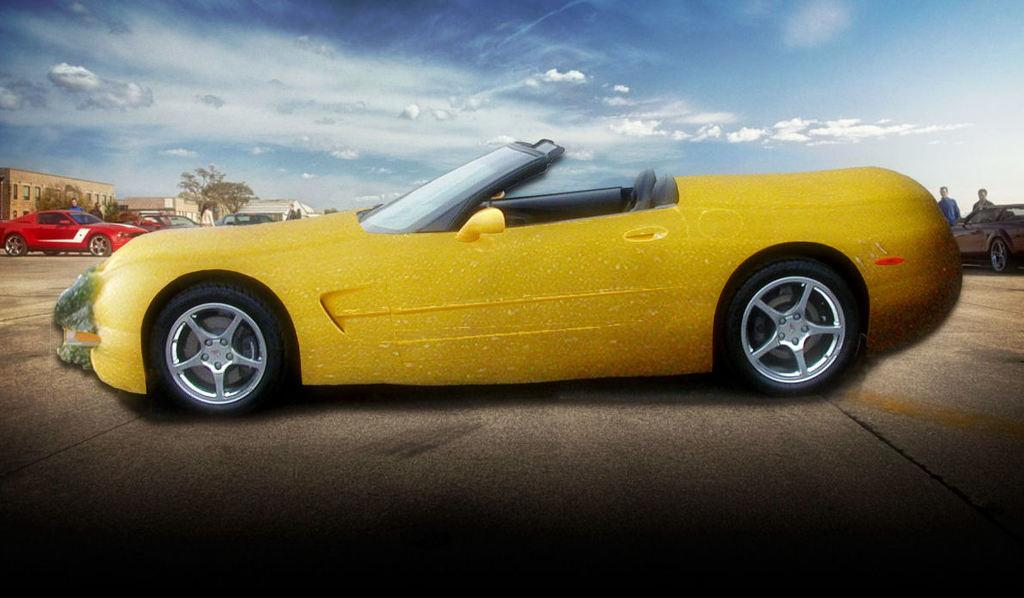What is the main subject of the image? The main subject of the image is a car on the road. What else can be seen in the background of the image? In the background, there are vehicles, people, trees, buildings, and clouds. How many types of objects can be seen in the background? There are five types of objects in the background: vehicles, people, trees, buildings, and clouds. What type of dress is the car wearing in the image? Cars do not wear dresses; they are inanimate objects. The question is not relevant to the image. 